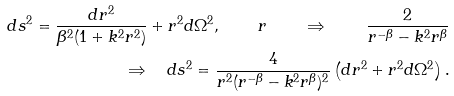<formula> <loc_0><loc_0><loc_500><loc_500>d s ^ { 2 } = \frac { d r ^ { 2 } } { \beta ^ { 2 } ( 1 + k ^ { 2 } r ^ { 2 } ) } + r ^ { 2 } d \Omega ^ { 2 } , \quad r \quad \Rightarrow \quad \frac { 2 } { r ^ { - \beta } - k ^ { 2 } r ^ { \beta } } \\ \Rightarrow \quad d s ^ { 2 } = \frac { 4 } { r ^ { 2 } ( r ^ { - \beta } - k ^ { 2 } r ^ { \beta } ) ^ { 2 } } \left ( d r ^ { 2 } + r ^ { 2 } d \Omega ^ { 2 } \right ) .</formula> 